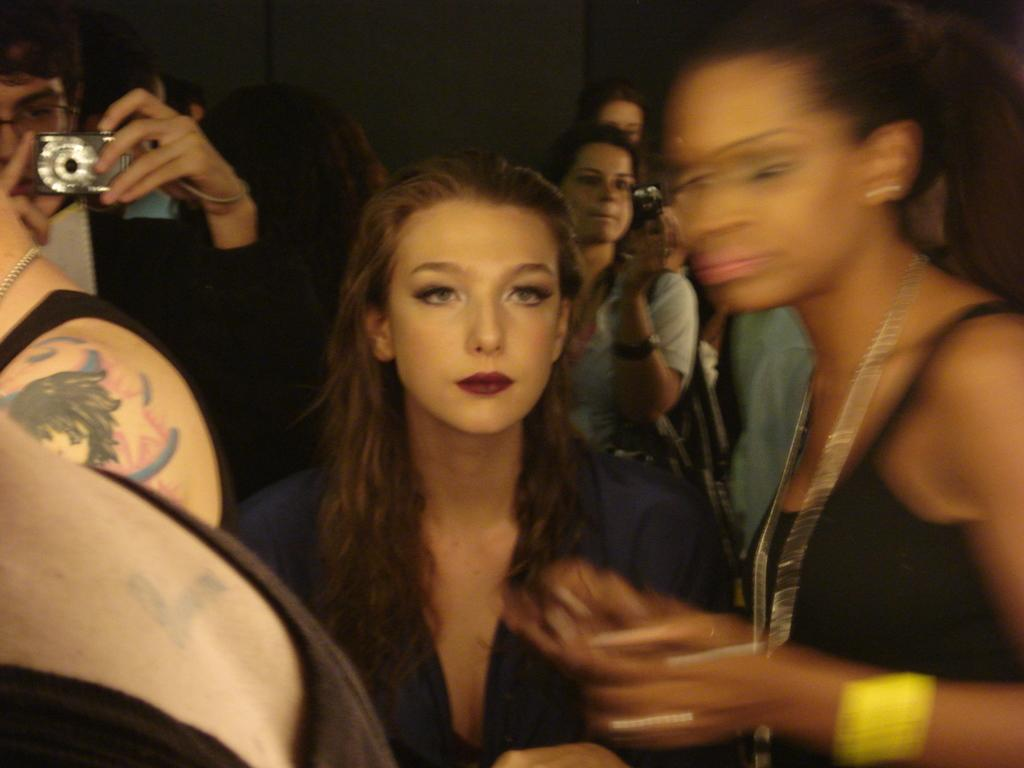What is the person in the image wearing? The person in the image is wearing a blue color dress. What is the person doing in the image? The person is standing. Where is the other person in the image located? There is a person at the left side of the image. What is the person at the left side holding? The person at the left side is holding a camera in his hand. What type of bead is being used to fix the stove in the image? There is no stove or bead present in the image. What color is the pail that the person is holding in the image? The person at the left side is not holding a pail; they are holding a camera. 